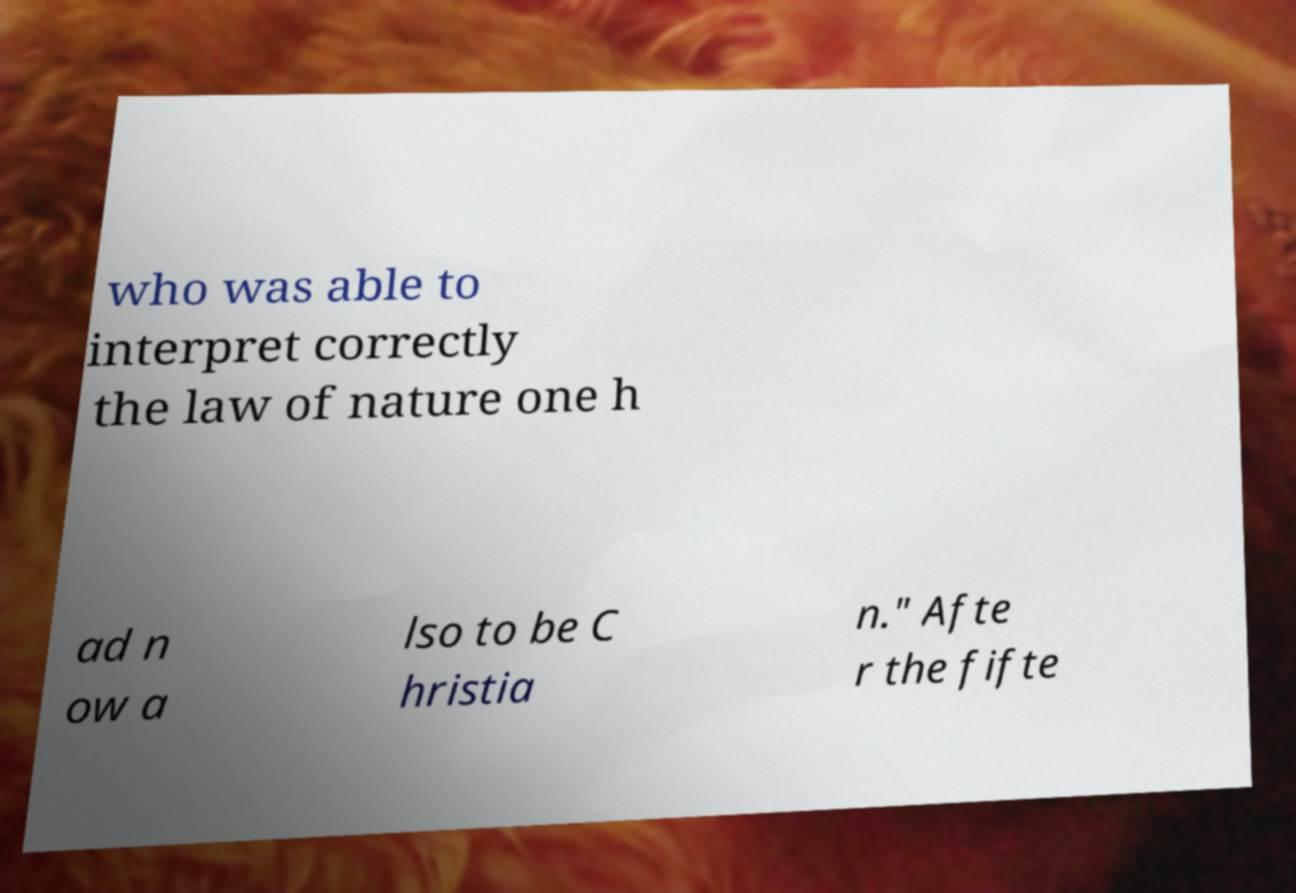Could you extract and type out the text from this image? who was able to interpret correctly the law of nature one h ad n ow a lso to be C hristia n." Afte r the fifte 